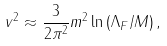Convert formula to latex. <formula><loc_0><loc_0><loc_500><loc_500>v ^ { 2 } \approx \frac { 3 } { 2 \pi ^ { 2 } } m ^ { 2 } \ln { ( \Lambda _ { F } / M ) } \, ,</formula> 